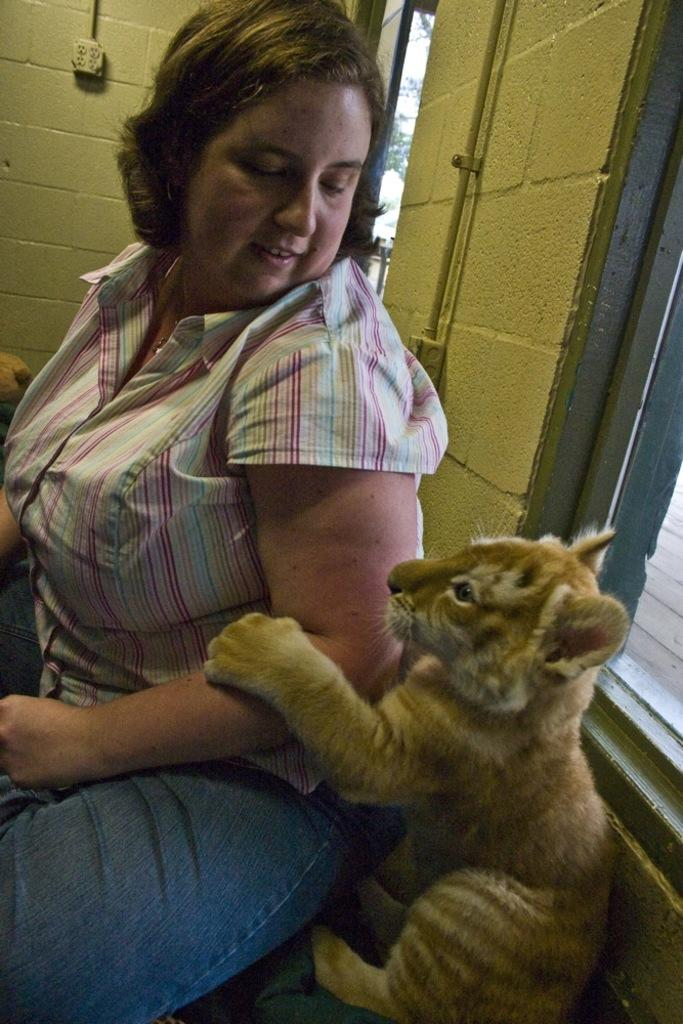What is the primary subject in the image? There is a woman seated in the image. Are there any animals present in the image? Yes, there is a lion cub in the image. What type of whistle is the lion cub using in the image? There is no whistle present in the image, as it features a woman seated and a lion cub. 